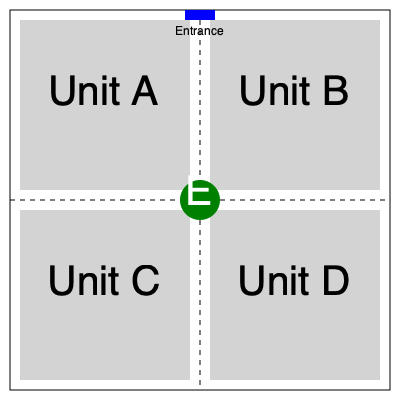Based on the floor plan provided, which unit would be most suitable for an elderly resident with mobility issues, considering proximity to the elevator and building entrance? To determine the most suitable unit for an elderly resident with mobility issues, we need to consider two main factors:

1. Proximity to the elevator (E):
   - All units are equidistant from the elevator, which is centrally located.

2. Proximity to the building entrance:
   - The entrance is located at the top of the floor plan.
   - Unit A and Unit B are closer to the entrance than Unit C and Unit D.

3. Comparing Unit A and Unit B:
   - Both are equally close to the elevator.
   - Both are equally close to the entrance.
   - However, Unit A is slightly closer to both the elevator and entrance corner, reducing the total walking distance.

4. Additional considerations:
   - Unit A requires no turns to reach the elevator or entrance, making it easier for someone with mobility issues to navigate.
   - Unit B requires one turn to reach the elevator and entrance, which might be slightly more challenging.

Given these factors, Unit A provides the most accessible and convenient location for an elderly resident with mobility issues.
Answer: Unit A 